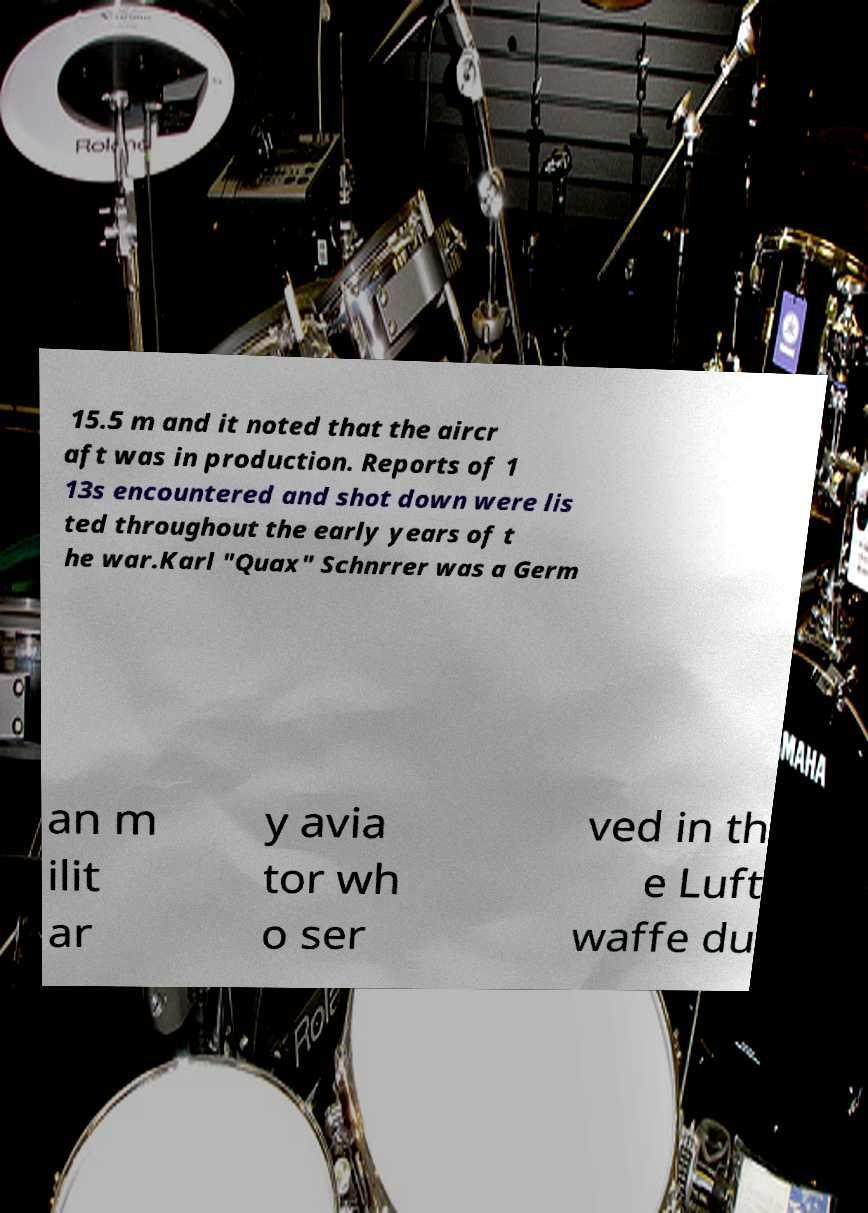Could you assist in decoding the text presented in this image and type it out clearly? 15.5 m and it noted that the aircr aft was in production. Reports of 1 13s encountered and shot down were lis ted throughout the early years of t he war.Karl "Quax" Schnrrer was a Germ an m ilit ar y avia tor wh o ser ved in th e Luft waffe du 